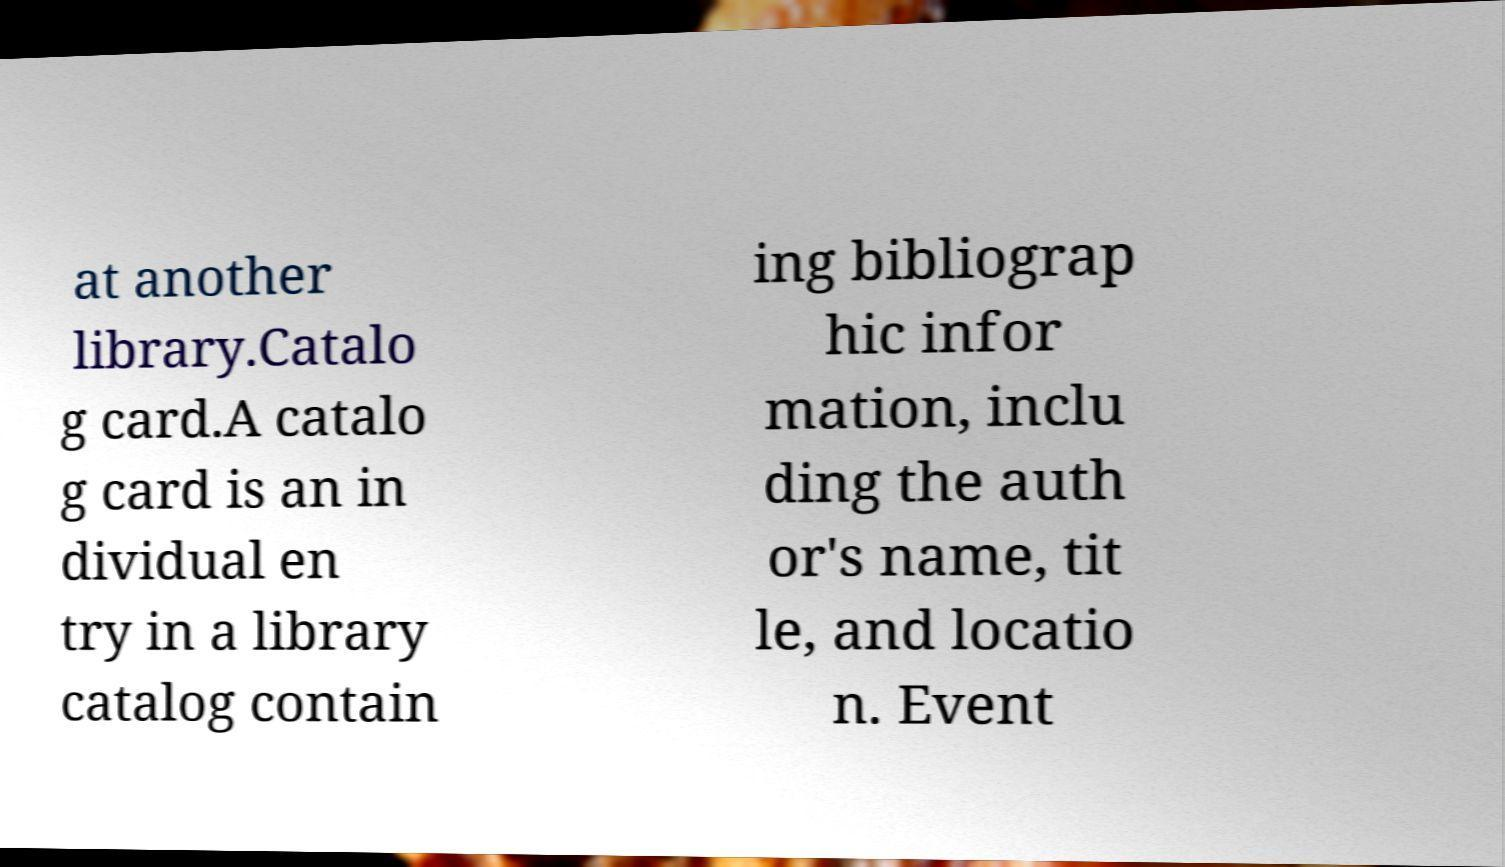Can you read and provide the text displayed in the image?This photo seems to have some interesting text. Can you extract and type it out for me? at another library.Catalo g card.A catalo g card is an in dividual en try in a library catalog contain ing bibliograp hic infor mation, inclu ding the auth or's name, tit le, and locatio n. Event 